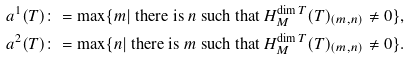Convert formula to latex. <formula><loc_0><loc_0><loc_500><loc_500>a ^ { 1 } ( T ) & \colon = \max \{ m | \ \text {there is $n$ such that $H_{M}^{\dim T}(T)_{(m,n)} \neq 0$} \} , \\ a ^ { 2 } ( T ) & \colon = \max \{ n | \ \text {there is $m$ such that $H_{M}^{\dim T}(T)_{(m,n)} \neq 0$} \} .</formula> 